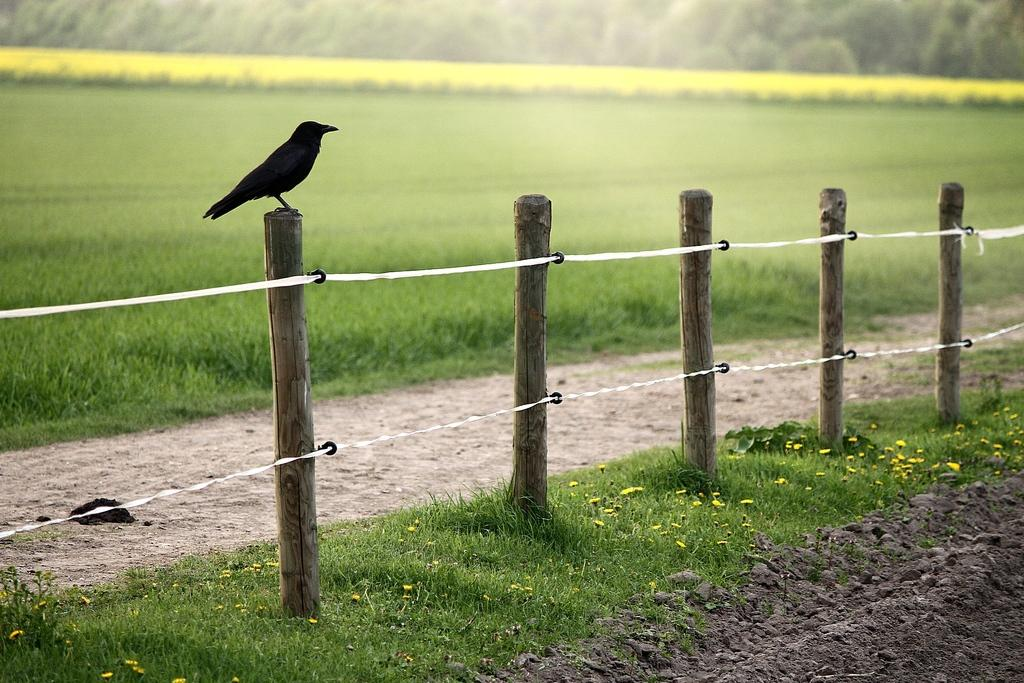What type of bird is in the image? There is a crow in the image. Where is the crow located? The crow is on a wooden fence. What can be seen in the background of the image? There is grass visible in the background of the image. What type of wood is the carpenter using to build the fence in the image? There is no carpenter or fence-building activity depicted in the image; it simply shows a crow on a wooden fence. 